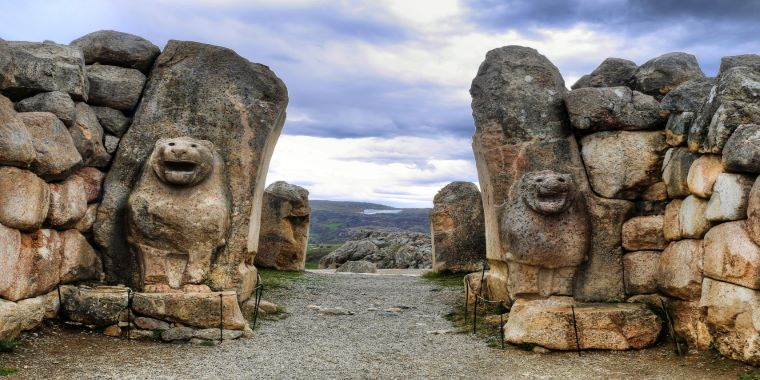What are the construction techniques visible in the gate's architecture? The Lion Gate of Hattusa showcases advanced construction techniques of the Hittites. The gate is built using large stone blocks, carefully cut and stacked without the use of mortar. This dry stone masonry technique reflects the Hittites' skill in stone working and engineering. The stones are uneven in size and shape, indicating they were chosen and shaped according to their intended position in the structure. This method not only provided stability but also resilience against earthquakes, common in this region. 